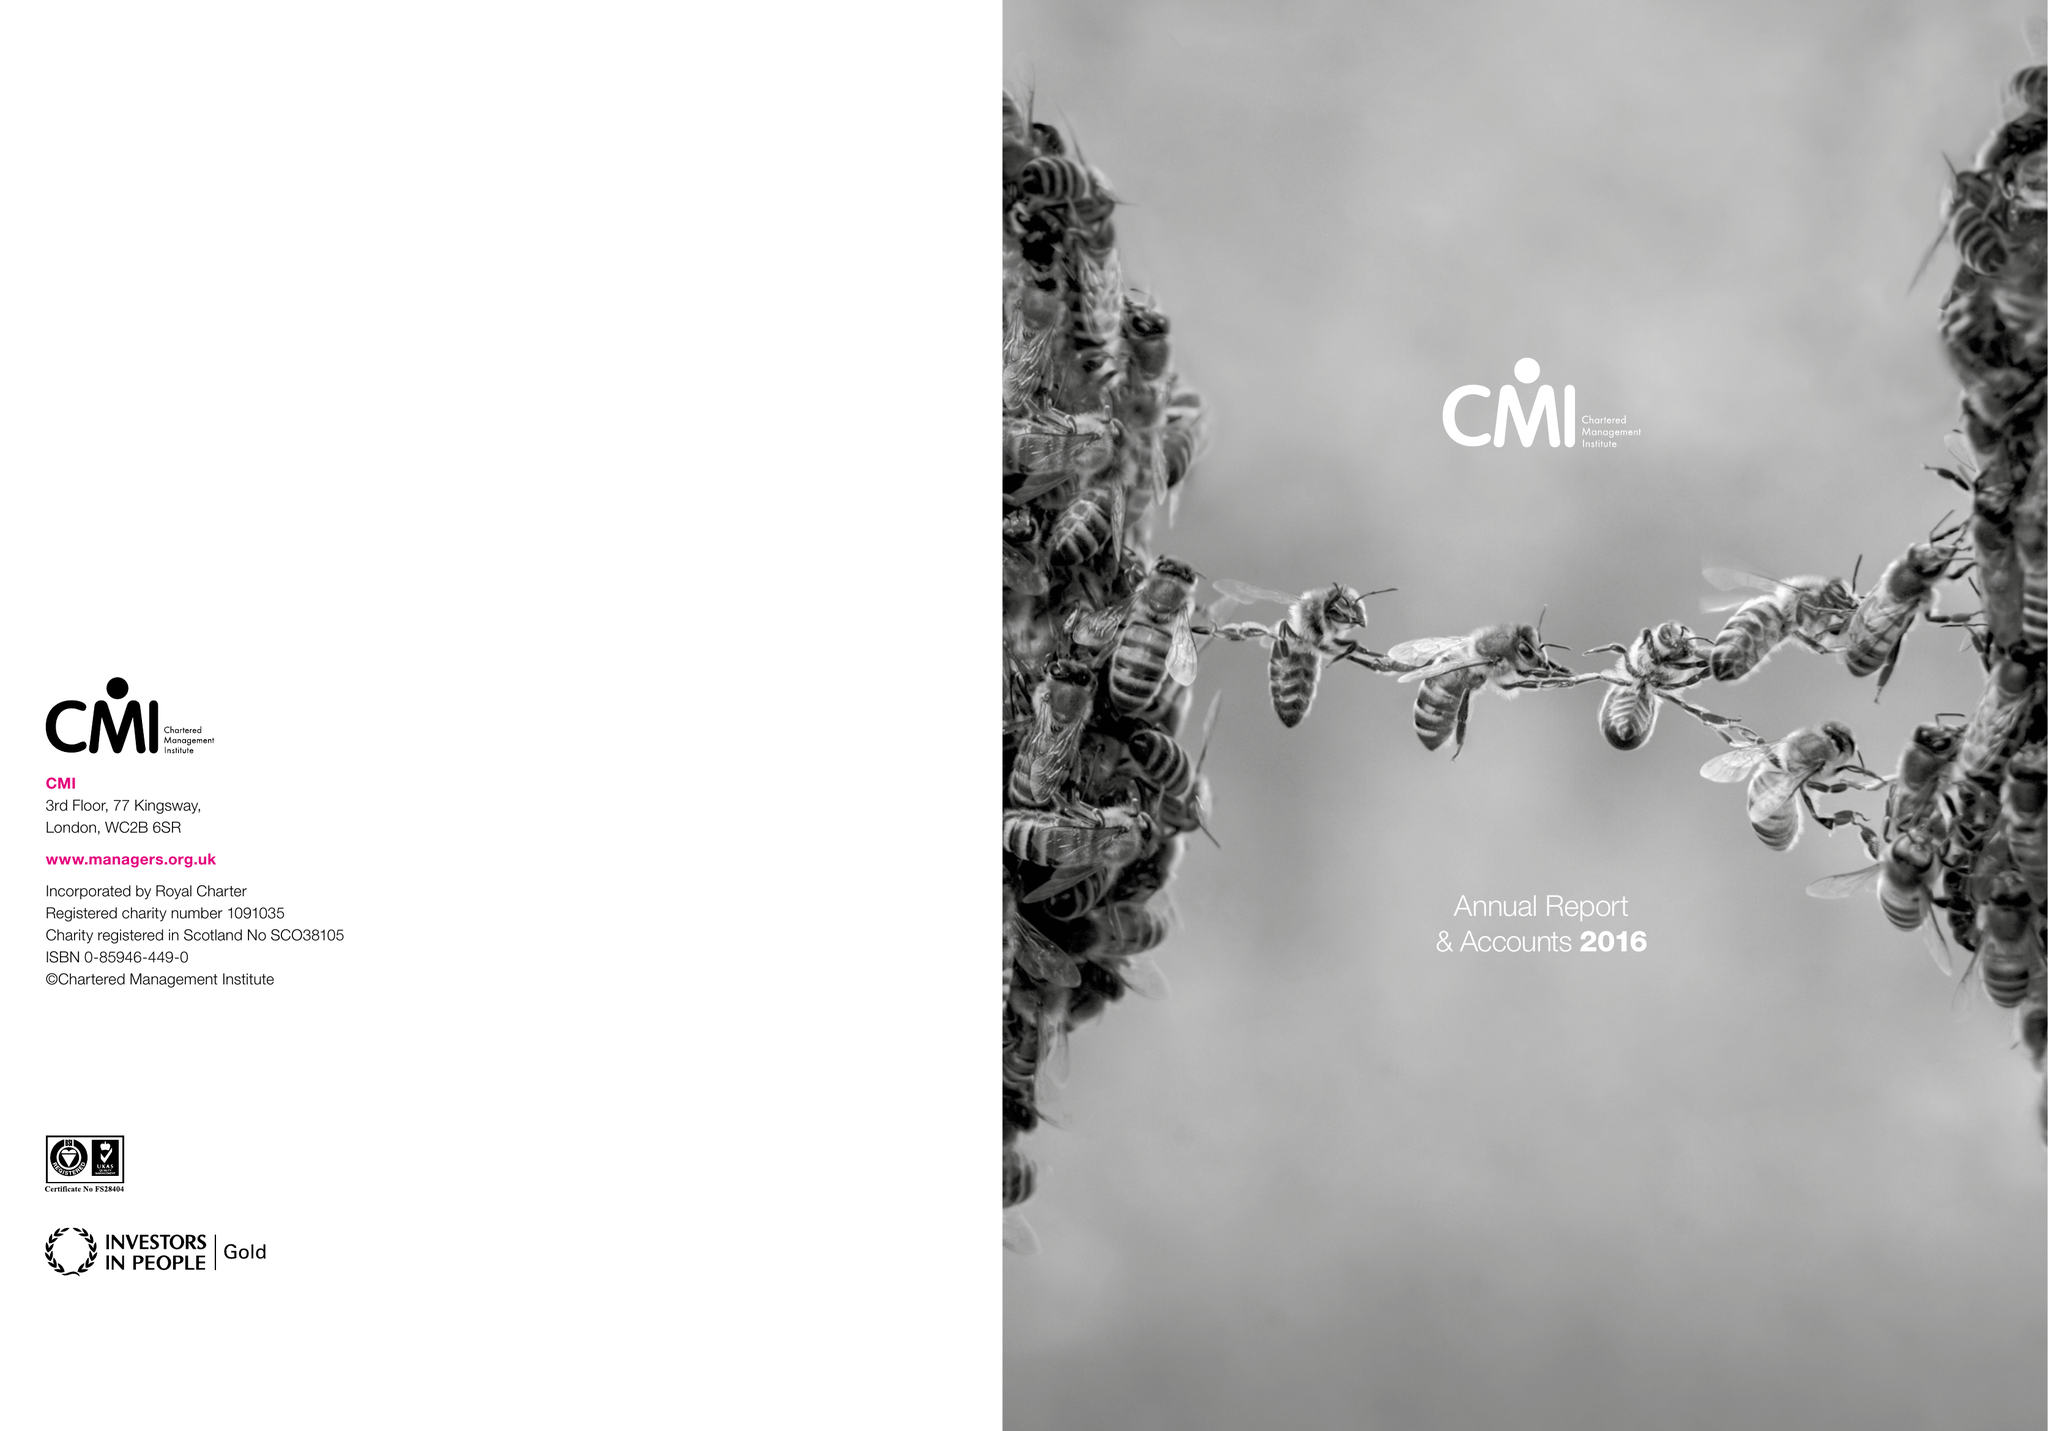What is the value for the address__postcode?
Answer the question using a single word or phrase. NN17 1TT 